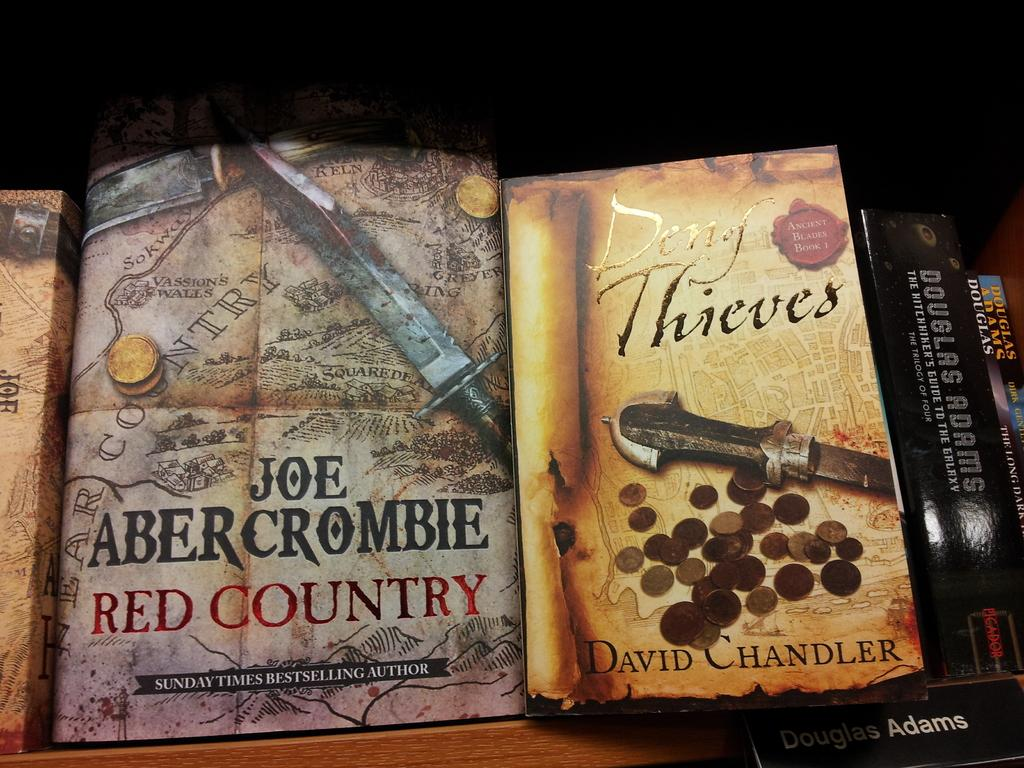<image>
Give a short and clear explanation of the subsequent image. A book with the title Joe Abercorombie Red Country beside the book Deny Thieves by Davide Chandler. 